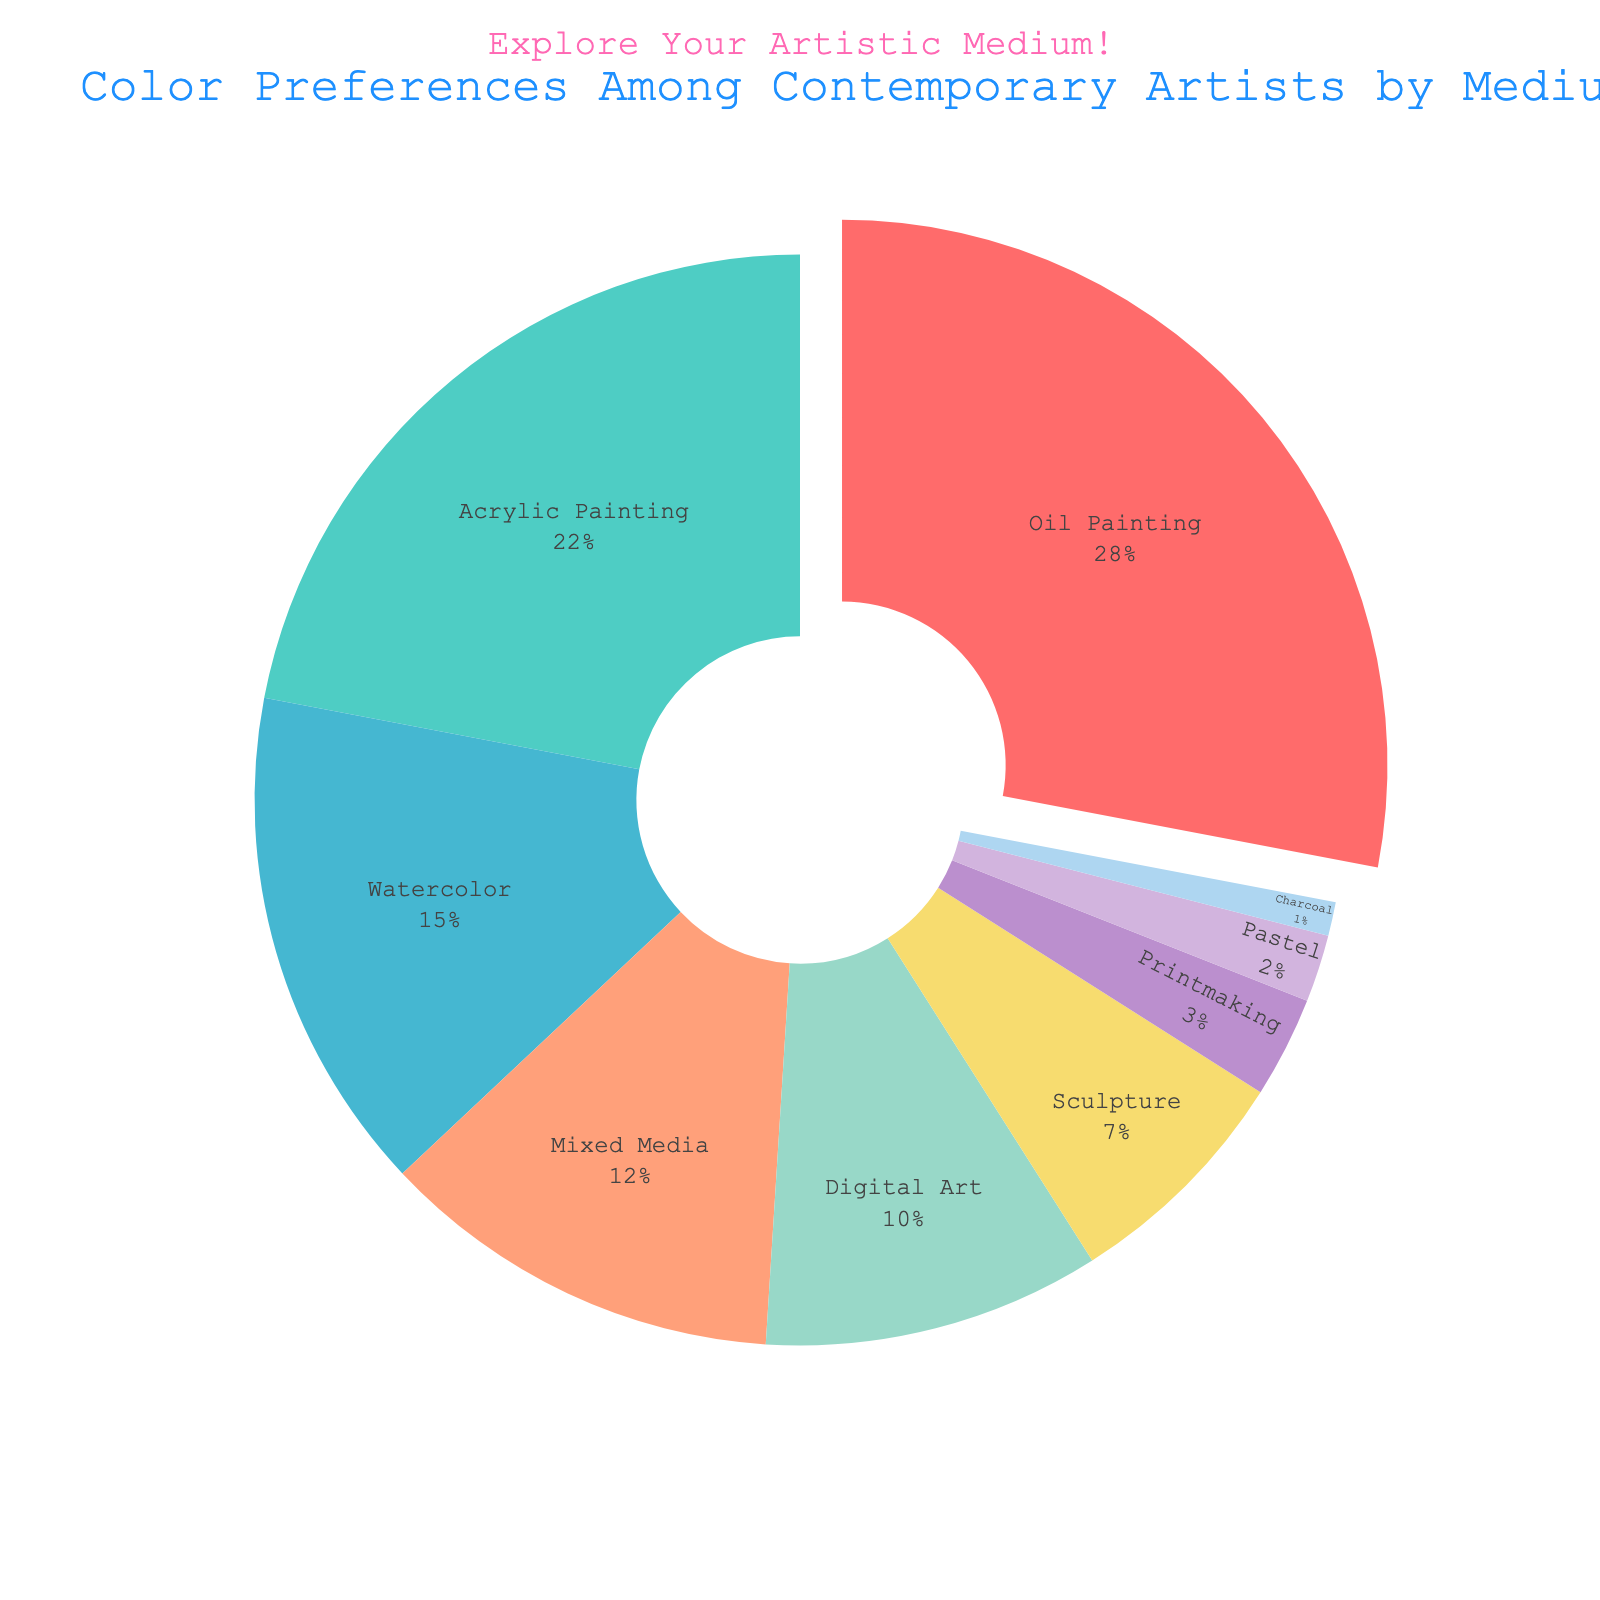What's the most preferred medium among contemporary artists? Looking at the pie chart, the segment labeled 'Oil Painting' occupies the largest portion of the chart.
Answer: Oil Painting Which mediums have a preference below 10%? Observing the pie chart, the segments labeled 'Digital Art', 'Sculpture', 'Printmaking', 'Pastel', and 'Charcoal' each represent less than 10% of the total preferences.
Answer: Digital Art, Sculpture, Printmaking, Pastel, Charcoal How much more popular is Acrylic Painting compared to Mixed Media? The percentage for Acrylic Painting is 22%, and for Mixed Media, it is 12%. Subtracting 12 from 22 gives the difference.
Answer: 10% Which medium is the least preferred? The smallest segment in the pie chart is labeled 'Charcoal'.
Answer: Charcoal What proportion of artists prefer either Watercolor or Mixed Media? Adding the percentages for Watercolor (15%) and Mixed Media (12%) gives the total preference for these two mediums.
Answer: 27% Compare the combined preference for Oil Painting and Acrylic Painting to that for Digital Art and Sculpture. Which is greater? Adding Oil Painting (28%) and Acrylic Painting (22%) gives 50%. Adding Digital Art (10%) and Sculpture (7%) gives 17%. Comparing these totals, 50% is greater.
Answer: Oil Painting and Acrylic Painting Which medium with more than 20% preference has a lower percentage than Oil Painting? In the pie chart, Oil Painting has a 28% preference. Acrylic Painting, with more than 20% preference, has 22%, which is lower than 28%.
Answer: Acrylic Painting What is the combined preference for all Painting mediums (Oil, Acrylic, Watercolor)? Adding the percentages for Oil Painting (28%), Acrylic Painting (22%), and Watercolor (15%) gives the total preference for painting mediums.
Answer: 65% Which mediums are represented with visually distinct colors such as bright or pastel? Referring to the color palette used in the pie chart, 'Oil Painting' (bright red), 'Acrylic Painting' (pastel turquoise), and 'Watercolor' (sky blue) are visually distinct.
Answer: Oil Painting, Acrylic Painting, Watercolor If you combine the preferences for Printmaking, Pastel, and Charcoal, do they sum up to more or less than the preference for Mixed Media? Summing up the percentages for Printmaking (3%), Pastel (2%), and Charcoal (1%) gives 6%. Comparing this to Mixed Media (12%), 6% is less than 12%.
Answer: Less 